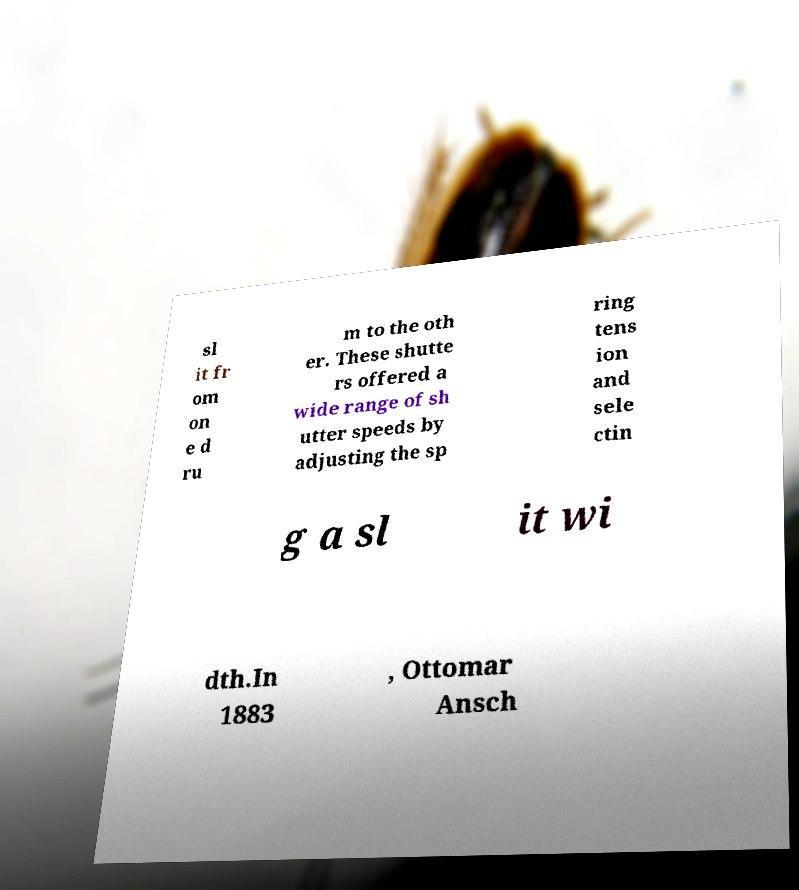What messages or text are displayed in this image? I need them in a readable, typed format. sl it fr om on e d ru m to the oth er. These shutte rs offered a wide range of sh utter speeds by adjusting the sp ring tens ion and sele ctin g a sl it wi dth.In 1883 , Ottomar Ansch 